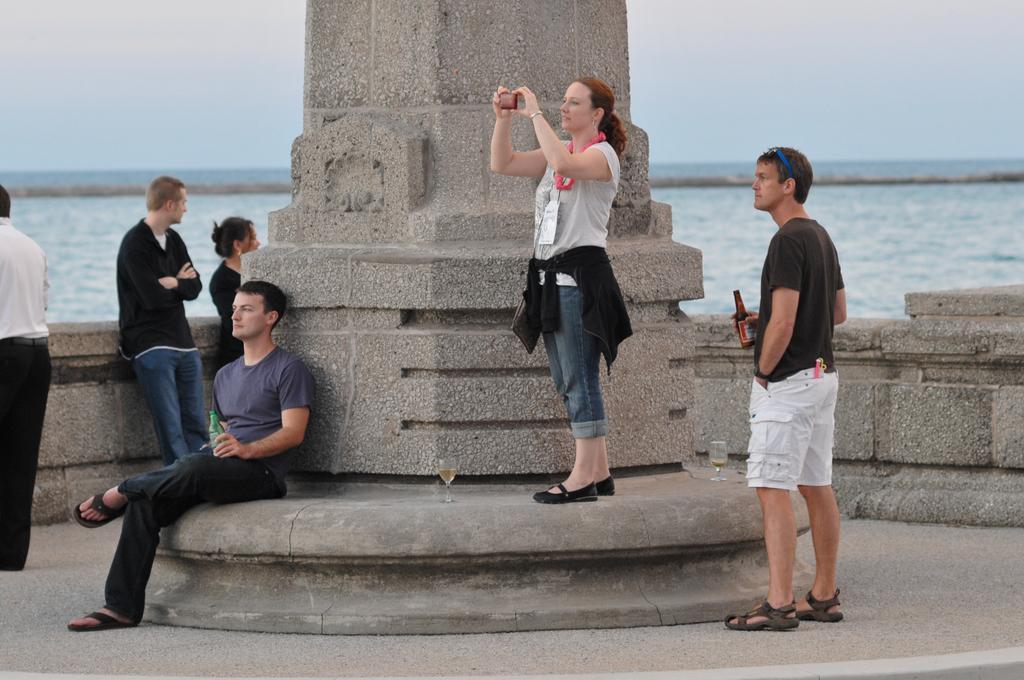Describe this image in one or two sentences. In this image we can see pillar, people and glasses. This woman is holding a mobile and wore a bag. These two people are holding bottles. Background we can see the sky and water. 